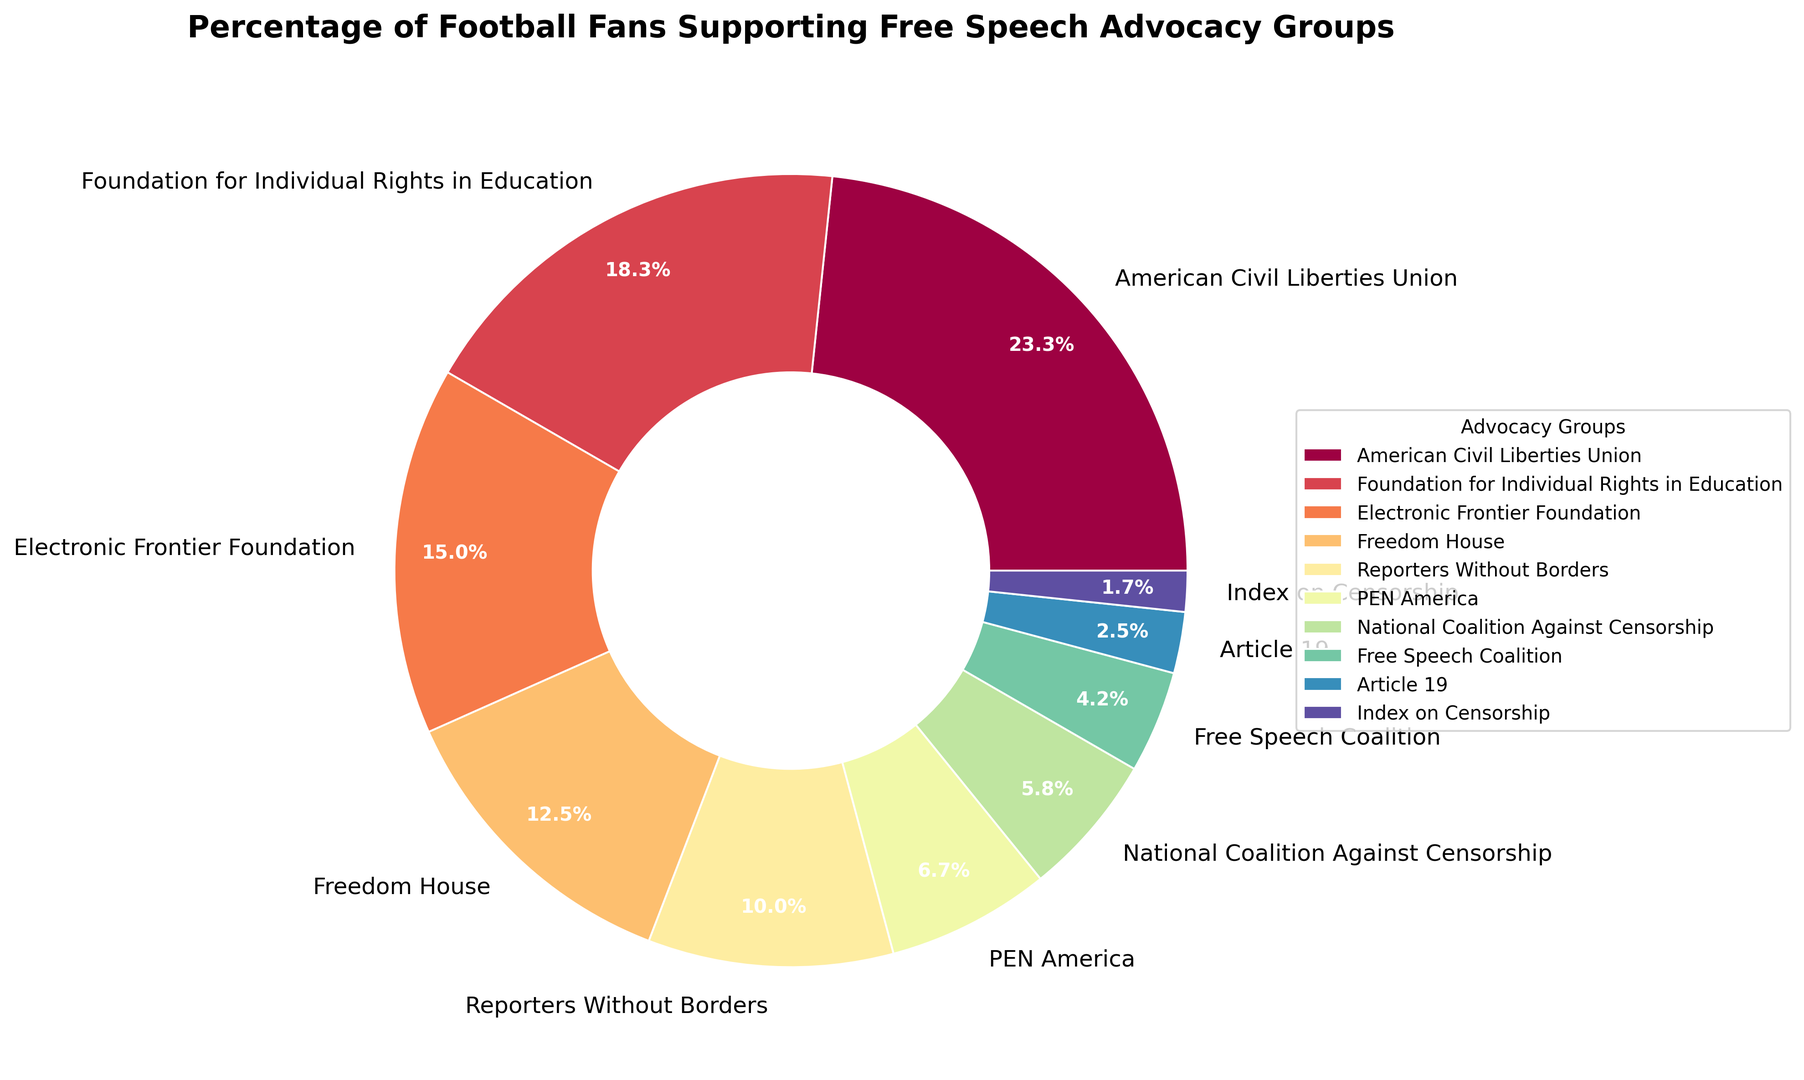Which group has the highest percentage of support among football fans? The figure shows that the American Civil Liberties Union has the largest segment of the pie chart.
Answer: American Civil Liberties Union Which groups have less than 10% support from football fans? The figure highlights the groups with segments smaller than others by looking at percentages in the wedges. These are PEN America, National Coalition Against Censorship, Free Speech Coalition, Article 19, and Index on Censorship.
Answer: PEN America, National Coalition Against Censorship, Free Speech Coalition, Article 19, Index on Censorship What is the combined support percentage for Electronic Frontier Foundation and Freedom House? The segment for Electronic Frontier Foundation is 18% and for Freedom House is 15%. Adding these together gives 18% + 15% = 33%.
Answer: 33% Which group has more support: Foundation for Individual Rights in Education or Freedom House? The figure shows that the Foundation for Individual Rights in Education has 22% while Freedom House has 15%. Therefore, the Foundation for Individual Rights in Education has more support.
Answer: Foundation for Individual Rights in Education How many groups have a support percentage greater than 20%? By examining the pie chart, we see two groups with segments exceeding 20%: American Civil Liberties Union (28%) and Foundation for Individual Rights in Education (22%).
Answer: 2 What is the total support percentage for the top three groups? The top three groups by support percentage are American Civil Liberties Union (28%), Foundation for Individual Rights in Education (22%), and Electronic Frontier Foundation (18%). Summing these gives 28% + 22% + 18% = 68%.
Answer: 68% Which group has the smallest support among football fans? The smallest segment of the pie chart is for Index on Censorship, with 2%.
Answer: Index on Censorship What is the difference in support between the Reporters Without Borders and PEN America? The figure shows Reporters Without Borders at 12% and PEN America at 8%. The difference is 12% - 8% = 4%.
Answer: 4% How does the support for Free Speech Coalition compare to the support for National Coalition Against Censorship? The pie chart illustrates that Free Speech Coalition has 5% support and National Coalition Against Censorship has 7%. Hence, National Coalition Against Censorship has more support.
Answer: National Coalition Against Censorship 